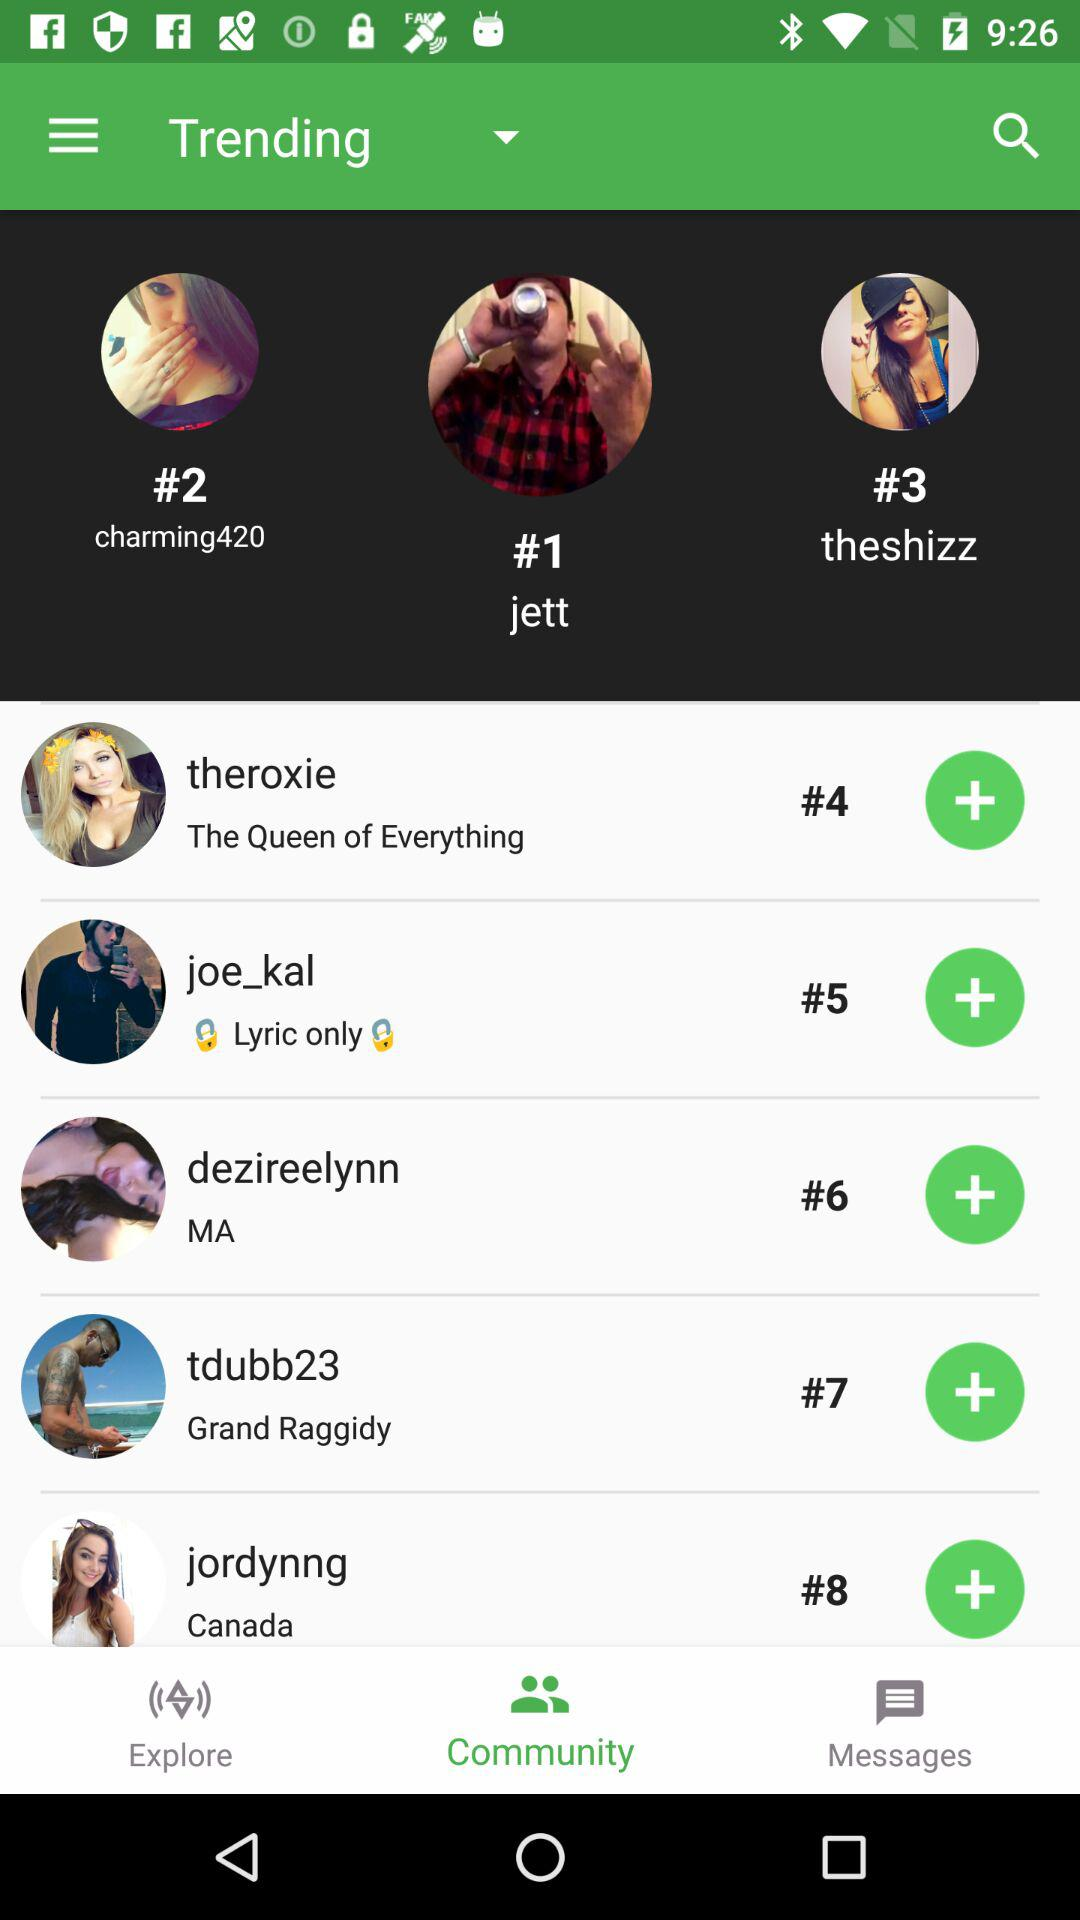Who is trending at #9?
When the provided information is insufficient, respond with <no answer>. <no answer> 